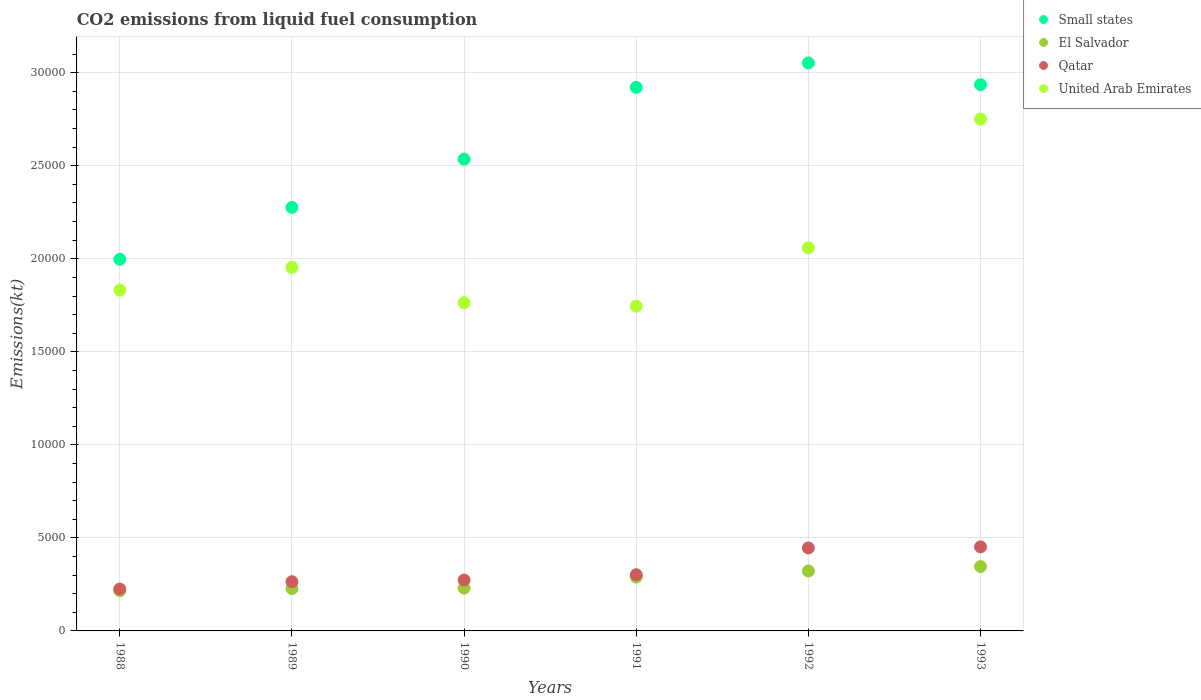Is the number of dotlines equal to the number of legend labels?
Make the answer very short. Yes. What is the amount of CO2 emitted in El Salvador in 1989?
Ensure brevity in your answer.  2273.54. Across all years, what is the maximum amount of CO2 emitted in Small states?
Make the answer very short. 3.05e+04. Across all years, what is the minimum amount of CO2 emitted in El Salvador?
Offer a terse response. 2159.86. In which year was the amount of CO2 emitted in Qatar minimum?
Provide a short and direct response. 1988. What is the total amount of CO2 emitted in El Salvador in the graph?
Offer a terse response. 1.63e+04. What is the difference between the amount of CO2 emitted in El Salvador in 1989 and that in 1991?
Your answer should be compact. -619.72. What is the difference between the amount of CO2 emitted in El Salvador in 1993 and the amount of CO2 emitted in Qatar in 1988?
Your answer should be compact. 1210.11. What is the average amount of CO2 emitted in Qatar per year?
Provide a short and direct response. 3271.58. In the year 1988, what is the difference between the amount of CO2 emitted in United Arab Emirates and amount of CO2 emitted in Small states?
Your answer should be compact. -1657.07. What is the ratio of the amount of CO2 emitted in El Salvador in 1989 to that in 1993?
Provide a succinct answer. 0.66. Is the difference between the amount of CO2 emitted in United Arab Emirates in 1988 and 1991 greater than the difference between the amount of CO2 emitted in Small states in 1988 and 1991?
Make the answer very short. Yes. What is the difference between the highest and the second highest amount of CO2 emitted in Qatar?
Your answer should be very brief. 58.67. What is the difference between the highest and the lowest amount of CO2 emitted in United Arab Emirates?
Provide a succinct answer. 1.01e+04. Is it the case that in every year, the sum of the amount of CO2 emitted in El Salvador and amount of CO2 emitted in Small states  is greater than the amount of CO2 emitted in Qatar?
Ensure brevity in your answer.  Yes. Is the amount of CO2 emitted in United Arab Emirates strictly less than the amount of CO2 emitted in Qatar over the years?
Provide a short and direct response. No. How many dotlines are there?
Your response must be concise. 4. How many years are there in the graph?
Your answer should be very brief. 6. What is the difference between two consecutive major ticks on the Y-axis?
Keep it short and to the point. 5000. Does the graph contain any zero values?
Provide a succinct answer. No. Where does the legend appear in the graph?
Your answer should be compact. Top right. How many legend labels are there?
Ensure brevity in your answer.  4. How are the legend labels stacked?
Your response must be concise. Vertical. What is the title of the graph?
Ensure brevity in your answer.  CO2 emissions from liquid fuel consumption. What is the label or title of the X-axis?
Your answer should be very brief. Years. What is the label or title of the Y-axis?
Give a very brief answer. Emissions(kt). What is the Emissions(kt) of Small states in 1988?
Provide a succinct answer. 2.00e+04. What is the Emissions(kt) of El Salvador in 1988?
Offer a terse response. 2159.86. What is the Emissions(kt) of Qatar in 1988?
Provide a succinct answer. 2251.54. What is the Emissions(kt) in United Arab Emirates in 1988?
Make the answer very short. 1.83e+04. What is the Emissions(kt) in Small states in 1989?
Provide a short and direct response. 2.28e+04. What is the Emissions(kt) of El Salvador in 1989?
Ensure brevity in your answer.  2273.54. What is the Emissions(kt) of Qatar in 1989?
Keep it short and to the point. 2643.91. What is the Emissions(kt) in United Arab Emirates in 1989?
Make the answer very short. 1.95e+04. What is the Emissions(kt) in Small states in 1990?
Keep it short and to the point. 2.54e+04. What is the Emissions(kt) in El Salvador in 1990?
Your answer should be compact. 2299.21. What is the Emissions(kt) of Qatar in 1990?
Offer a very short reply. 2735.58. What is the Emissions(kt) in United Arab Emirates in 1990?
Provide a short and direct response. 1.76e+04. What is the Emissions(kt) of Small states in 1991?
Make the answer very short. 2.92e+04. What is the Emissions(kt) of El Salvador in 1991?
Offer a very short reply. 2893.26. What is the Emissions(kt) in Qatar in 1991?
Offer a terse response. 3021.61. What is the Emissions(kt) of United Arab Emirates in 1991?
Make the answer very short. 1.75e+04. What is the Emissions(kt) of Small states in 1992?
Give a very brief answer. 3.05e+04. What is the Emissions(kt) of El Salvador in 1992?
Your answer should be very brief. 3219.63. What is the Emissions(kt) in Qatar in 1992?
Your response must be concise. 4459.07. What is the Emissions(kt) of United Arab Emirates in 1992?
Make the answer very short. 2.06e+04. What is the Emissions(kt) in Small states in 1993?
Provide a short and direct response. 2.94e+04. What is the Emissions(kt) of El Salvador in 1993?
Keep it short and to the point. 3461.65. What is the Emissions(kt) of Qatar in 1993?
Your answer should be compact. 4517.74. What is the Emissions(kt) in United Arab Emirates in 1993?
Your response must be concise. 2.75e+04. Across all years, what is the maximum Emissions(kt) in Small states?
Provide a short and direct response. 3.05e+04. Across all years, what is the maximum Emissions(kt) in El Salvador?
Provide a short and direct response. 3461.65. Across all years, what is the maximum Emissions(kt) in Qatar?
Your answer should be very brief. 4517.74. Across all years, what is the maximum Emissions(kt) in United Arab Emirates?
Ensure brevity in your answer.  2.75e+04. Across all years, what is the minimum Emissions(kt) of Small states?
Ensure brevity in your answer.  2.00e+04. Across all years, what is the minimum Emissions(kt) in El Salvador?
Offer a terse response. 2159.86. Across all years, what is the minimum Emissions(kt) of Qatar?
Provide a succinct answer. 2251.54. Across all years, what is the minimum Emissions(kt) in United Arab Emirates?
Ensure brevity in your answer.  1.75e+04. What is the total Emissions(kt) in Small states in the graph?
Your answer should be compact. 1.57e+05. What is the total Emissions(kt) of El Salvador in the graph?
Your answer should be compact. 1.63e+04. What is the total Emissions(kt) in Qatar in the graph?
Keep it short and to the point. 1.96e+04. What is the total Emissions(kt) in United Arab Emirates in the graph?
Your answer should be compact. 1.21e+05. What is the difference between the Emissions(kt) of Small states in 1988 and that in 1989?
Keep it short and to the point. -2788.3. What is the difference between the Emissions(kt) of El Salvador in 1988 and that in 1989?
Keep it short and to the point. -113.68. What is the difference between the Emissions(kt) in Qatar in 1988 and that in 1989?
Make the answer very short. -392.37. What is the difference between the Emissions(kt) in United Arab Emirates in 1988 and that in 1989?
Make the answer very short. -1221.11. What is the difference between the Emissions(kt) of Small states in 1988 and that in 1990?
Provide a short and direct response. -5381.89. What is the difference between the Emissions(kt) in El Salvador in 1988 and that in 1990?
Provide a short and direct response. -139.35. What is the difference between the Emissions(kt) of Qatar in 1988 and that in 1990?
Provide a succinct answer. -484.04. What is the difference between the Emissions(kt) in United Arab Emirates in 1988 and that in 1990?
Keep it short and to the point. 678.39. What is the difference between the Emissions(kt) in Small states in 1988 and that in 1991?
Keep it short and to the point. -9239.76. What is the difference between the Emissions(kt) in El Salvador in 1988 and that in 1991?
Provide a succinct answer. -733.4. What is the difference between the Emissions(kt) in Qatar in 1988 and that in 1991?
Ensure brevity in your answer.  -770.07. What is the difference between the Emissions(kt) in United Arab Emirates in 1988 and that in 1991?
Keep it short and to the point. 865.41. What is the difference between the Emissions(kt) in Small states in 1988 and that in 1992?
Make the answer very short. -1.06e+04. What is the difference between the Emissions(kt) of El Salvador in 1988 and that in 1992?
Provide a succinct answer. -1059.76. What is the difference between the Emissions(kt) of Qatar in 1988 and that in 1992?
Ensure brevity in your answer.  -2207.53. What is the difference between the Emissions(kt) of United Arab Emirates in 1988 and that in 1992?
Provide a short and direct response. -2273.54. What is the difference between the Emissions(kt) of Small states in 1988 and that in 1993?
Keep it short and to the point. -9383.36. What is the difference between the Emissions(kt) of El Salvador in 1988 and that in 1993?
Offer a terse response. -1301.79. What is the difference between the Emissions(kt) of Qatar in 1988 and that in 1993?
Provide a succinct answer. -2266.21. What is the difference between the Emissions(kt) in United Arab Emirates in 1988 and that in 1993?
Offer a terse response. -9196.84. What is the difference between the Emissions(kt) of Small states in 1989 and that in 1990?
Keep it short and to the point. -2593.59. What is the difference between the Emissions(kt) in El Salvador in 1989 and that in 1990?
Give a very brief answer. -25.67. What is the difference between the Emissions(kt) in Qatar in 1989 and that in 1990?
Your answer should be very brief. -91.67. What is the difference between the Emissions(kt) in United Arab Emirates in 1989 and that in 1990?
Make the answer very short. 1899.51. What is the difference between the Emissions(kt) in Small states in 1989 and that in 1991?
Provide a succinct answer. -6451.46. What is the difference between the Emissions(kt) of El Salvador in 1989 and that in 1991?
Make the answer very short. -619.72. What is the difference between the Emissions(kt) of Qatar in 1989 and that in 1991?
Your response must be concise. -377.7. What is the difference between the Emissions(kt) of United Arab Emirates in 1989 and that in 1991?
Ensure brevity in your answer.  2086.52. What is the difference between the Emissions(kt) of Small states in 1989 and that in 1992?
Offer a very short reply. -7763.29. What is the difference between the Emissions(kt) of El Salvador in 1989 and that in 1992?
Offer a very short reply. -946.09. What is the difference between the Emissions(kt) of Qatar in 1989 and that in 1992?
Your response must be concise. -1815.16. What is the difference between the Emissions(kt) of United Arab Emirates in 1989 and that in 1992?
Give a very brief answer. -1052.43. What is the difference between the Emissions(kt) of Small states in 1989 and that in 1993?
Your response must be concise. -6595.06. What is the difference between the Emissions(kt) in El Salvador in 1989 and that in 1993?
Ensure brevity in your answer.  -1188.11. What is the difference between the Emissions(kt) in Qatar in 1989 and that in 1993?
Give a very brief answer. -1873.84. What is the difference between the Emissions(kt) of United Arab Emirates in 1989 and that in 1993?
Provide a short and direct response. -7975.73. What is the difference between the Emissions(kt) of Small states in 1990 and that in 1991?
Your answer should be compact. -3857.87. What is the difference between the Emissions(kt) in El Salvador in 1990 and that in 1991?
Make the answer very short. -594.05. What is the difference between the Emissions(kt) of Qatar in 1990 and that in 1991?
Make the answer very short. -286.03. What is the difference between the Emissions(kt) of United Arab Emirates in 1990 and that in 1991?
Offer a terse response. 187.02. What is the difference between the Emissions(kt) in Small states in 1990 and that in 1992?
Keep it short and to the point. -5169.71. What is the difference between the Emissions(kt) in El Salvador in 1990 and that in 1992?
Give a very brief answer. -920.42. What is the difference between the Emissions(kt) of Qatar in 1990 and that in 1992?
Make the answer very short. -1723.49. What is the difference between the Emissions(kt) in United Arab Emirates in 1990 and that in 1992?
Make the answer very short. -2951.93. What is the difference between the Emissions(kt) of Small states in 1990 and that in 1993?
Your response must be concise. -4001.48. What is the difference between the Emissions(kt) of El Salvador in 1990 and that in 1993?
Offer a terse response. -1162.44. What is the difference between the Emissions(kt) in Qatar in 1990 and that in 1993?
Your response must be concise. -1782.16. What is the difference between the Emissions(kt) in United Arab Emirates in 1990 and that in 1993?
Offer a terse response. -9875.23. What is the difference between the Emissions(kt) of Small states in 1991 and that in 1992?
Keep it short and to the point. -1311.83. What is the difference between the Emissions(kt) in El Salvador in 1991 and that in 1992?
Give a very brief answer. -326.36. What is the difference between the Emissions(kt) of Qatar in 1991 and that in 1992?
Your response must be concise. -1437.46. What is the difference between the Emissions(kt) of United Arab Emirates in 1991 and that in 1992?
Keep it short and to the point. -3138.95. What is the difference between the Emissions(kt) of Small states in 1991 and that in 1993?
Make the answer very short. -143.6. What is the difference between the Emissions(kt) in El Salvador in 1991 and that in 1993?
Offer a terse response. -568.38. What is the difference between the Emissions(kt) of Qatar in 1991 and that in 1993?
Ensure brevity in your answer.  -1496.14. What is the difference between the Emissions(kt) of United Arab Emirates in 1991 and that in 1993?
Your answer should be very brief. -1.01e+04. What is the difference between the Emissions(kt) in Small states in 1992 and that in 1993?
Offer a terse response. 1168.23. What is the difference between the Emissions(kt) of El Salvador in 1992 and that in 1993?
Your response must be concise. -242.02. What is the difference between the Emissions(kt) of Qatar in 1992 and that in 1993?
Your answer should be compact. -58.67. What is the difference between the Emissions(kt) in United Arab Emirates in 1992 and that in 1993?
Give a very brief answer. -6923.3. What is the difference between the Emissions(kt) in Small states in 1988 and the Emissions(kt) in El Salvador in 1989?
Offer a terse response. 1.77e+04. What is the difference between the Emissions(kt) in Small states in 1988 and the Emissions(kt) in Qatar in 1989?
Offer a terse response. 1.73e+04. What is the difference between the Emissions(kt) of Small states in 1988 and the Emissions(kt) of United Arab Emirates in 1989?
Provide a succinct answer. 435.96. What is the difference between the Emissions(kt) in El Salvador in 1988 and the Emissions(kt) in Qatar in 1989?
Keep it short and to the point. -484.04. What is the difference between the Emissions(kt) in El Salvador in 1988 and the Emissions(kt) in United Arab Emirates in 1989?
Offer a terse response. -1.74e+04. What is the difference between the Emissions(kt) in Qatar in 1988 and the Emissions(kt) in United Arab Emirates in 1989?
Provide a short and direct response. -1.73e+04. What is the difference between the Emissions(kt) in Small states in 1988 and the Emissions(kt) in El Salvador in 1990?
Your answer should be compact. 1.77e+04. What is the difference between the Emissions(kt) of Small states in 1988 and the Emissions(kt) of Qatar in 1990?
Offer a terse response. 1.72e+04. What is the difference between the Emissions(kt) in Small states in 1988 and the Emissions(kt) in United Arab Emirates in 1990?
Provide a succinct answer. 2335.46. What is the difference between the Emissions(kt) in El Salvador in 1988 and the Emissions(kt) in Qatar in 1990?
Offer a terse response. -575.72. What is the difference between the Emissions(kt) of El Salvador in 1988 and the Emissions(kt) of United Arab Emirates in 1990?
Offer a very short reply. -1.55e+04. What is the difference between the Emissions(kt) of Qatar in 1988 and the Emissions(kt) of United Arab Emirates in 1990?
Give a very brief answer. -1.54e+04. What is the difference between the Emissions(kt) in Small states in 1988 and the Emissions(kt) in El Salvador in 1991?
Your answer should be compact. 1.71e+04. What is the difference between the Emissions(kt) of Small states in 1988 and the Emissions(kt) of Qatar in 1991?
Your answer should be very brief. 1.70e+04. What is the difference between the Emissions(kt) in Small states in 1988 and the Emissions(kt) in United Arab Emirates in 1991?
Keep it short and to the point. 2522.48. What is the difference between the Emissions(kt) in El Salvador in 1988 and the Emissions(kt) in Qatar in 1991?
Your answer should be very brief. -861.75. What is the difference between the Emissions(kt) in El Salvador in 1988 and the Emissions(kt) in United Arab Emirates in 1991?
Make the answer very short. -1.53e+04. What is the difference between the Emissions(kt) in Qatar in 1988 and the Emissions(kt) in United Arab Emirates in 1991?
Your answer should be very brief. -1.52e+04. What is the difference between the Emissions(kt) of Small states in 1988 and the Emissions(kt) of El Salvador in 1992?
Your answer should be very brief. 1.68e+04. What is the difference between the Emissions(kt) in Small states in 1988 and the Emissions(kt) in Qatar in 1992?
Give a very brief answer. 1.55e+04. What is the difference between the Emissions(kt) of Small states in 1988 and the Emissions(kt) of United Arab Emirates in 1992?
Provide a short and direct response. -616.47. What is the difference between the Emissions(kt) of El Salvador in 1988 and the Emissions(kt) of Qatar in 1992?
Your response must be concise. -2299.21. What is the difference between the Emissions(kt) in El Salvador in 1988 and the Emissions(kt) in United Arab Emirates in 1992?
Make the answer very short. -1.84e+04. What is the difference between the Emissions(kt) of Qatar in 1988 and the Emissions(kt) of United Arab Emirates in 1992?
Provide a short and direct response. -1.83e+04. What is the difference between the Emissions(kt) in Small states in 1988 and the Emissions(kt) in El Salvador in 1993?
Your answer should be compact. 1.65e+04. What is the difference between the Emissions(kt) in Small states in 1988 and the Emissions(kt) in Qatar in 1993?
Your response must be concise. 1.55e+04. What is the difference between the Emissions(kt) of Small states in 1988 and the Emissions(kt) of United Arab Emirates in 1993?
Give a very brief answer. -7539.77. What is the difference between the Emissions(kt) in El Salvador in 1988 and the Emissions(kt) in Qatar in 1993?
Offer a very short reply. -2357.88. What is the difference between the Emissions(kt) in El Salvador in 1988 and the Emissions(kt) in United Arab Emirates in 1993?
Provide a short and direct response. -2.54e+04. What is the difference between the Emissions(kt) in Qatar in 1988 and the Emissions(kt) in United Arab Emirates in 1993?
Keep it short and to the point. -2.53e+04. What is the difference between the Emissions(kt) in Small states in 1989 and the Emissions(kt) in El Salvador in 1990?
Offer a terse response. 2.05e+04. What is the difference between the Emissions(kt) of Small states in 1989 and the Emissions(kt) of Qatar in 1990?
Offer a terse response. 2.00e+04. What is the difference between the Emissions(kt) of Small states in 1989 and the Emissions(kt) of United Arab Emirates in 1990?
Keep it short and to the point. 5123.76. What is the difference between the Emissions(kt) of El Salvador in 1989 and the Emissions(kt) of Qatar in 1990?
Your answer should be compact. -462.04. What is the difference between the Emissions(kt) in El Salvador in 1989 and the Emissions(kt) in United Arab Emirates in 1990?
Make the answer very short. -1.54e+04. What is the difference between the Emissions(kt) in Qatar in 1989 and the Emissions(kt) in United Arab Emirates in 1990?
Give a very brief answer. -1.50e+04. What is the difference between the Emissions(kt) in Small states in 1989 and the Emissions(kt) in El Salvador in 1991?
Your response must be concise. 1.99e+04. What is the difference between the Emissions(kt) in Small states in 1989 and the Emissions(kt) in Qatar in 1991?
Give a very brief answer. 1.97e+04. What is the difference between the Emissions(kt) in Small states in 1989 and the Emissions(kt) in United Arab Emirates in 1991?
Give a very brief answer. 5310.78. What is the difference between the Emissions(kt) in El Salvador in 1989 and the Emissions(kt) in Qatar in 1991?
Provide a short and direct response. -748.07. What is the difference between the Emissions(kt) of El Salvador in 1989 and the Emissions(kt) of United Arab Emirates in 1991?
Give a very brief answer. -1.52e+04. What is the difference between the Emissions(kt) in Qatar in 1989 and the Emissions(kt) in United Arab Emirates in 1991?
Provide a short and direct response. -1.48e+04. What is the difference between the Emissions(kt) in Small states in 1989 and the Emissions(kt) in El Salvador in 1992?
Ensure brevity in your answer.  1.95e+04. What is the difference between the Emissions(kt) of Small states in 1989 and the Emissions(kt) of Qatar in 1992?
Make the answer very short. 1.83e+04. What is the difference between the Emissions(kt) in Small states in 1989 and the Emissions(kt) in United Arab Emirates in 1992?
Your response must be concise. 2171.83. What is the difference between the Emissions(kt) in El Salvador in 1989 and the Emissions(kt) in Qatar in 1992?
Ensure brevity in your answer.  -2185.53. What is the difference between the Emissions(kt) of El Salvador in 1989 and the Emissions(kt) of United Arab Emirates in 1992?
Your answer should be very brief. -1.83e+04. What is the difference between the Emissions(kt) of Qatar in 1989 and the Emissions(kt) of United Arab Emirates in 1992?
Your response must be concise. -1.79e+04. What is the difference between the Emissions(kt) in Small states in 1989 and the Emissions(kt) in El Salvador in 1993?
Your response must be concise. 1.93e+04. What is the difference between the Emissions(kt) in Small states in 1989 and the Emissions(kt) in Qatar in 1993?
Offer a terse response. 1.82e+04. What is the difference between the Emissions(kt) in Small states in 1989 and the Emissions(kt) in United Arab Emirates in 1993?
Give a very brief answer. -4751.47. What is the difference between the Emissions(kt) of El Salvador in 1989 and the Emissions(kt) of Qatar in 1993?
Your response must be concise. -2244.2. What is the difference between the Emissions(kt) in El Salvador in 1989 and the Emissions(kt) in United Arab Emirates in 1993?
Ensure brevity in your answer.  -2.52e+04. What is the difference between the Emissions(kt) in Qatar in 1989 and the Emissions(kt) in United Arab Emirates in 1993?
Ensure brevity in your answer.  -2.49e+04. What is the difference between the Emissions(kt) in Small states in 1990 and the Emissions(kt) in El Salvador in 1991?
Provide a short and direct response. 2.25e+04. What is the difference between the Emissions(kt) of Small states in 1990 and the Emissions(kt) of Qatar in 1991?
Your response must be concise. 2.23e+04. What is the difference between the Emissions(kt) in Small states in 1990 and the Emissions(kt) in United Arab Emirates in 1991?
Your answer should be very brief. 7904.37. What is the difference between the Emissions(kt) of El Salvador in 1990 and the Emissions(kt) of Qatar in 1991?
Provide a succinct answer. -722.4. What is the difference between the Emissions(kt) of El Salvador in 1990 and the Emissions(kt) of United Arab Emirates in 1991?
Provide a short and direct response. -1.52e+04. What is the difference between the Emissions(kt) in Qatar in 1990 and the Emissions(kt) in United Arab Emirates in 1991?
Your answer should be very brief. -1.47e+04. What is the difference between the Emissions(kt) in Small states in 1990 and the Emissions(kt) in El Salvador in 1992?
Give a very brief answer. 2.21e+04. What is the difference between the Emissions(kt) in Small states in 1990 and the Emissions(kt) in Qatar in 1992?
Your answer should be very brief. 2.09e+04. What is the difference between the Emissions(kt) in Small states in 1990 and the Emissions(kt) in United Arab Emirates in 1992?
Offer a very short reply. 4765.41. What is the difference between the Emissions(kt) in El Salvador in 1990 and the Emissions(kt) in Qatar in 1992?
Give a very brief answer. -2159.86. What is the difference between the Emissions(kt) in El Salvador in 1990 and the Emissions(kt) in United Arab Emirates in 1992?
Make the answer very short. -1.83e+04. What is the difference between the Emissions(kt) in Qatar in 1990 and the Emissions(kt) in United Arab Emirates in 1992?
Make the answer very short. -1.79e+04. What is the difference between the Emissions(kt) of Small states in 1990 and the Emissions(kt) of El Salvador in 1993?
Offer a terse response. 2.19e+04. What is the difference between the Emissions(kt) of Small states in 1990 and the Emissions(kt) of Qatar in 1993?
Make the answer very short. 2.08e+04. What is the difference between the Emissions(kt) of Small states in 1990 and the Emissions(kt) of United Arab Emirates in 1993?
Provide a succinct answer. -2157.88. What is the difference between the Emissions(kt) of El Salvador in 1990 and the Emissions(kt) of Qatar in 1993?
Your answer should be very brief. -2218.53. What is the difference between the Emissions(kt) in El Salvador in 1990 and the Emissions(kt) in United Arab Emirates in 1993?
Offer a very short reply. -2.52e+04. What is the difference between the Emissions(kt) in Qatar in 1990 and the Emissions(kt) in United Arab Emirates in 1993?
Provide a short and direct response. -2.48e+04. What is the difference between the Emissions(kt) of Small states in 1991 and the Emissions(kt) of El Salvador in 1992?
Ensure brevity in your answer.  2.60e+04. What is the difference between the Emissions(kt) of Small states in 1991 and the Emissions(kt) of Qatar in 1992?
Your answer should be compact. 2.48e+04. What is the difference between the Emissions(kt) in Small states in 1991 and the Emissions(kt) in United Arab Emirates in 1992?
Provide a short and direct response. 8623.29. What is the difference between the Emissions(kt) in El Salvador in 1991 and the Emissions(kt) in Qatar in 1992?
Keep it short and to the point. -1565.81. What is the difference between the Emissions(kt) in El Salvador in 1991 and the Emissions(kt) in United Arab Emirates in 1992?
Make the answer very short. -1.77e+04. What is the difference between the Emissions(kt) in Qatar in 1991 and the Emissions(kt) in United Arab Emirates in 1992?
Offer a very short reply. -1.76e+04. What is the difference between the Emissions(kt) of Small states in 1991 and the Emissions(kt) of El Salvador in 1993?
Keep it short and to the point. 2.58e+04. What is the difference between the Emissions(kt) of Small states in 1991 and the Emissions(kt) of Qatar in 1993?
Make the answer very short. 2.47e+04. What is the difference between the Emissions(kt) of Small states in 1991 and the Emissions(kt) of United Arab Emirates in 1993?
Your response must be concise. 1699.99. What is the difference between the Emissions(kt) of El Salvador in 1991 and the Emissions(kt) of Qatar in 1993?
Keep it short and to the point. -1624.48. What is the difference between the Emissions(kt) in El Salvador in 1991 and the Emissions(kt) in United Arab Emirates in 1993?
Your answer should be compact. -2.46e+04. What is the difference between the Emissions(kt) in Qatar in 1991 and the Emissions(kt) in United Arab Emirates in 1993?
Keep it short and to the point. -2.45e+04. What is the difference between the Emissions(kt) of Small states in 1992 and the Emissions(kt) of El Salvador in 1993?
Ensure brevity in your answer.  2.71e+04. What is the difference between the Emissions(kt) in Small states in 1992 and the Emissions(kt) in Qatar in 1993?
Give a very brief answer. 2.60e+04. What is the difference between the Emissions(kt) of Small states in 1992 and the Emissions(kt) of United Arab Emirates in 1993?
Give a very brief answer. 3011.82. What is the difference between the Emissions(kt) in El Salvador in 1992 and the Emissions(kt) in Qatar in 1993?
Your response must be concise. -1298.12. What is the difference between the Emissions(kt) of El Salvador in 1992 and the Emissions(kt) of United Arab Emirates in 1993?
Provide a short and direct response. -2.43e+04. What is the difference between the Emissions(kt) in Qatar in 1992 and the Emissions(kt) in United Arab Emirates in 1993?
Keep it short and to the point. -2.31e+04. What is the average Emissions(kt) of Small states per year?
Offer a very short reply. 2.62e+04. What is the average Emissions(kt) in El Salvador per year?
Provide a short and direct response. 2717.86. What is the average Emissions(kt) of Qatar per year?
Provide a short and direct response. 3271.58. What is the average Emissions(kt) of United Arab Emirates per year?
Your response must be concise. 2.02e+04. In the year 1988, what is the difference between the Emissions(kt) in Small states and Emissions(kt) in El Salvador?
Give a very brief answer. 1.78e+04. In the year 1988, what is the difference between the Emissions(kt) in Small states and Emissions(kt) in Qatar?
Keep it short and to the point. 1.77e+04. In the year 1988, what is the difference between the Emissions(kt) in Small states and Emissions(kt) in United Arab Emirates?
Keep it short and to the point. 1657.07. In the year 1988, what is the difference between the Emissions(kt) of El Salvador and Emissions(kt) of Qatar?
Your response must be concise. -91.67. In the year 1988, what is the difference between the Emissions(kt) of El Salvador and Emissions(kt) of United Arab Emirates?
Offer a very short reply. -1.62e+04. In the year 1988, what is the difference between the Emissions(kt) of Qatar and Emissions(kt) of United Arab Emirates?
Your response must be concise. -1.61e+04. In the year 1989, what is the difference between the Emissions(kt) in Small states and Emissions(kt) in El Salvador?
Ensure brevity in your answer.  2.05e+04. In the year 1989, what is the difference between the Emissions(kt) of Small states and Emissions(kt) of Qatar?
Your answer should be compact. 2.01e+04. In the year 1989, what is the difference between the Emissions(kt) of Small states and Emissions(kt) of United Arab Emirates?
Your answer should be very brief. 3224.26. In the year 1989, what is the difference between the Emissions(kt) in El Salvador and Emissions(kt) in Qatar?
Ensure brevity in your answer.  -370.37. In the year 1989, what is the difference between the Emissions(kt) in El Salvador and Emissions(kt) in United Arab Emirates?
Your answer should be very brief. -1.73e+04. In the year 1989, what is the difference between the Emissions(kt) in Qatar and Emissions(kt) in United Arab Emirates?
Your response must be concise. -1.69e+04. In the year 1990, what is the difference between the Emissions(kt) in Small states and Emissions(kt) in El Salvador?
Make the answer very short. 2.31e+04. In the year 1990, what is the difference between the Emissions(kt) of Small states and Emissions(kt) of Qatar?
Offer a very short reply. 2.26e+04. In the year 1990, what is the difference between the Emissions(kt) in Small states and Emissions(kt) in United Arab Emirates?
Offer a terse response. 7717.35. In the year 1990, what is the difference between the Emissions(kt) of El Salvador and Emissions(kt) of Qatar?
Your answer should be compact. -436.37. In the year 1990, what is the difference between the Emissions(kt) in El Salvador and Emissions(kt) in United Arab Emirates?
Offer a very short reply. -1.53e+04. In the year 1990, what is the difference between the Emissions(kt) in Qatar and Emissions(kt) in United Arab Emirates?
Ensure brevity in your answer.  -1.49e+04. In the year 1991, what is the difference between the Emissions(kt) in Small states and Emissions(kt) in El Salvador?
Give a very brief answer. 2.63e+04. In the year 1991, what is the difference between the Emissions(kt) of Small states and Emissions(kt) of Qatar?
Offer a terse response. 2.62e+04. In the year 1991, what is the difference between the Emissions(kt) of Small states and Emissions(kt) of United Arab Emirates?
Keep it short and to the point. 1.18e+04. In the year 1991, what is the difference between the Emissions(kt) of El Salvador and Emissions(kt) of Qatar?
Give a very brief answer. -128.34. In the year 1991, what is the difference between the Emissions(kt) in El Salvador and Emissions(kt) in United Arab Emirates?
Provide a succinct answer. -1.46e+04. In the year 1991, what is the difference between the Emissions(kt) in Qatar and Emissions(kt) in United Arab Emirates?
Your response must be concise. -1.44e+04. In the year 1992, what is the difference between the Emissions(kt) in Small states and Emissions(kt) in El Salvador?
Offer a very short reply. 2.73e+04. In the year 1992, what is the difference between the Emissions(kt) in Small states and Emissions(kt) in Qatar?
Keep it short and to the point. 2.61e+04. In the year 1992, what is the difference between the Emissions(kt) in Small states and Emissions(kt) in United Arab Emirates?
Your response must be concise. 9935.12. In the year 1992, what is the difference between the Emissions(kt) in El Salvador and Emissions(kt) in Qatar?
Your answer should be compact. -1239.45. In the year 1992, what is the difference between the Emissions(kt) of El Salvador and Emissions(kt) of United Arab Emirates?
Keep it short and to the point. -1.74e+04. In the year 1992, what is the difference between the Emissions(kt) in Qatar and Emissions(kt) in United Arab Emirates?
Give a very brief answer. -1.61e+04. In the year 1993, what is the difference between the Emissions(kt) of Small states and Emissions(kt) of El Salvador?
Provide a succinct answer. 2.59e+04. In the year 1993, what is the difference between the Emissions(kt) of Small states and Emissions(kt) of Qatar?
Provide a succinct answer. 2.48e+04. In the year 1993, what is the difference between the Emissions(kt) in Small states and Emissions(kt) in United Arab Emirates?
Your answer should be compact. 1843.59. In the year 1993, what is the difference between the Emissions(kt) of El Salvador and Emissions(kt) of Qatar?
Give a very brief answer. -1056.1. In the year 1993, what is the difference between the Emissions(kt) of El Salvador and Emissions(kt) of United Arab Emirates?
Your response must be concise. -2.41e+04. In the year 1993, what is the difference between the Emissions(kt) of Qatar and Emissions(kt) of United Arab Emirates?
Your answer should be very brief. -2.30e+04. What is the ratio of the Emissions(kt) in Small states in 1988 to that in 1989?
Your response must be concise. 0.88. What is the ratio of the Emissions(kt) of Qatar in 1988 to that in 1989?
Provide a succinct answer. 0.85. What is the ratio of the Emissions(kt) in United Arab Emirates in 1988 to that in 1989?
Offer a terse response. 0.94. What is the ratio of the Emissions(kt) of Small states in 1988 to that in 1990?
Provide a short and direct response. 0.79. What is the ratio of the Emissions(kt) in El Salvador in 1988 to that in 1990?
Ensure brevity in your answer.  0.94. What is the ratio of the Emissions(kt) in Qatar in 1988 to that in 1990?
Provide a short and direct response. 0.82. What is the ratio of the Emissions(kt) in United Arab Emirates in 1988 to that in 1990?
Offer a terse response. 1.04. What is the ratio of the Emissions(kt) of Small states in 1988 to that in 1991?
Offer a terse response. 0.68. What is the ratio of the Emissions(kt) of El Salvador in 1988 to that in 1991?
Provide a succinct answer. 0.75. What is the ratio of the Emissions(kt) in Qatar in 1988 to that in 1991?
Your response must be concise. 0.75. What is the ratio of the Emissions(kt) of United Arab Emirates in 1988 to that in 1991?
Provide a succinct answer. 1.05. What is the ratio of the Emissions(kt) in Small states in 1988 to that in 1992?
Keep it short and to the point. 0.65. What is the ratio of the Emissions(kt) in El Salvador in 1988 to that in 1992?
Keep it short and to the point. 0.67. What is the ratio of the Emissions(kt) of Qatar in 1988 to that in 1992?
Ensure brevity in your answer.  0.5. What is the ratio of the Emissions(kt) in United Arab Emirates in 1988 to that in 1992?
Your response must be concise. 0.89. What is the ratio of the Emissions(kt) in Small states in 1988 to that in 1993?
Make the answer very short. 0.68. What is the ratio of the Emissions(kt) in El Salvador in 1988 to that in 1993?
Your answer should be very brief. 0.62. What is the ratio of the Emissions(kt) of Qatar in 1988 to that in 1993?
Your response must be concise. 0.5. What is the ratio of the Emissions(kt) in United Arab Emirates in 1988 to that in 1993?
Make the answer very short. 0.67. What is the ratio of the Emissions(kt) in Small states in 1989 to that in 1990?
Offer a terse response. 0.9. What is the ratio of the Emissions(kt) of Qatar in 1989 to that in 1990?
Give a very brief answer. 0.97. What is the ratio of the Emissions(kt) of United Arab Emirates in 1989 to that in 1990?
Offer a terse response. 1.11. What is the ratio of the Emissions(kt) in Small states in 1989 to that in 1991?
Offer a terse response. 0.78. What is the ratio of the Emissions(kt) of El Salvador in 1989 to that in 1991?
Offer a very short reply. 0.79. What is the ratio of the Emissions(kt) of United Arab Emirates in 1989 to that in 1991?
Keep it short and to the point. 1.12. What is the ratio of the Emissions(kt) of Small states in 1989 to that in 1992?
Your response must be concise. 0.75. What is the ratio of the Emissions(kt) in El Salvador in 1989 to that in 1992?
Offer a very short reply. 0.71. What is the ratio of the Emissions(kt) in Qatar in 1989 to that in 1992?
Keep it short and to the point. 0.59. What is the ratio of the Emissions(kt) in United Arab Emirates in 1989 to that in 1992?
Your answer should be very brief. 0.95. What is the ratio of the Emissions(kt) in Small states in 1989 to that in 1993?
Ensure brevity in your answer.  0.78. What is the ratio of the Emissions(kt) of El Salvador in 1989 to that in 1993?
Provide a short and direct response. 0.66. What is the ratio of the Emissions(kt) of Qatar in 1989 to that in 1993?
Your answer should be very brief. 0.59. What is the ratio of the Emissions(kt) in United Arab Emirates in 1989 to that in 1993?
Keep it short and to the point. 0.71. What is the ratio of the Emissions(kt) of Small states in 1990 to that in 1991?
Give a very brief answer. 0.87. What is the ratio of the Emissions(kt) in El Salvador in 1990 to that in 1991?
Your answer should be compact. 0.79. What is the ratio of the Emissions(kt) in Qatar in 1990 to that in 1991?
Offer a very short reply. 0.91. What is the ratio of the Emissions(kt) in United Arab Emirates in 1990 to that in 1991?
Give a very brief answer. 1.01. What is the ratio of the Emissions(kt) of Small states in 1990 to that in 1992?
Keep it short and to the point. 0.83. What is the ratio of the Emissions(kt) of El Salvador in 1990 to that in 1992?
Offer a terse response. 0.71. What is the ratio of the Emissions(kt) in Qatar in 1990 to that in 1992?
Provide a short and direct response. 0.61. What is the ratio of the Emissions(kt) in United Arab Emirates in 1990 to that in 1992?
Ensure brevity in your answer.  0.86. What is the ratio of the Emissions(kt) of Small states in 1990 to that in 1993?
Provide a short and direct response. 0.86. What is the ratio of the Emissions(kt) in El Salvador in 1990 to that in 1993?
Your response must be concise. 0.66. What is the ratio of the Emissions(kt) of Qatar in 1990 to that in 1993?
Offer a terse response. 0.61. What is the ratio of the Emissions(kt) of United Arab Emirates in 1990 to that in 1993?
Provide a short and direct response. 0.64. What is the ratio of the Emissions(kt) of Small states in 1991 to that in 1992?
Give a very brief answer. 0.96. What is the ratio of the Emissions(kt) of El Salvador in 1991 to that in 1992?
Your answer should be very brief. 0.9. What is the ratio of the Emissions(kt) of Qatar in 1991 to that in 1992?
Make the answer very short. 0.68. What is the ratio of the Emissions(kt) in United Arab Emirates in 1991 to that in 1992?
Give a very brief answer. 0.85. What is the ratio of the Emissions(kt) in Small states in 1991 to that in 1993?
Make the answer very short. 1. What is the ratio of the Emissions(kt) of El Salvador in 1991 to that in 1993?
Offer a terse response. 0.84. What is the ratio of the Emissions(kt) in Qatar in 1991 to that in 1993?
Make the answer very short. 0.67. What is the ratio of the Emissions(kt) of United Arab Emirates in 1991 to that in 1993?
Ensure brevity in your answer.  0.63. What is the ratio of the Emissions(kt) of Small states in 1992 to that in 1993?
Keep it short and to the point. 1.04. What is the ratio of the Emissions(kt) in El Salvador in 1992 to that in 1993?
Give a very brief answer. 0.93. What is the ratio of the Emissions(kt) in Qatar in 1992 to that in 1993?
Provide a short and direct response. 0.99. What is the ratio of the Emissions(kt) of United Arab Emirates in 1992 to that in 1993?
Provide a succinct answer. 0.75. What is the difference between the highest and the second highest Emissions(kt) of Small states?
Give a very brief answer. 1168.23. What is the difference between the highest and the second highest Emissions(kt) of El Salvador?
Make the answer very short. 242.02. What is the difference between the highest and the second highest Emissions(kt) of Qatar?
Give a very brief answer. 58.67. What is the difference between the highest and the second highest Emissions(kt) in United Arab Emirates?
Your response must be concise. 6923.3. What is the difference between the highest and the lowest Emissions(kt) of Small states?
Offer a very short reply. 1.06e+04. What is the difference between the highest and the lowest Emissions(kt) of El Salvador?
Provide a short and direct response. 1301.79. What is the difference between the highest and the lowest Emissions(kt) of Qatar?
Your answer should be very brief. 2266.21. What is the difference between the highest and the lowest Emissions(kt) of United Arab Emirates?
Make the answer very short. 1.01e+04. 